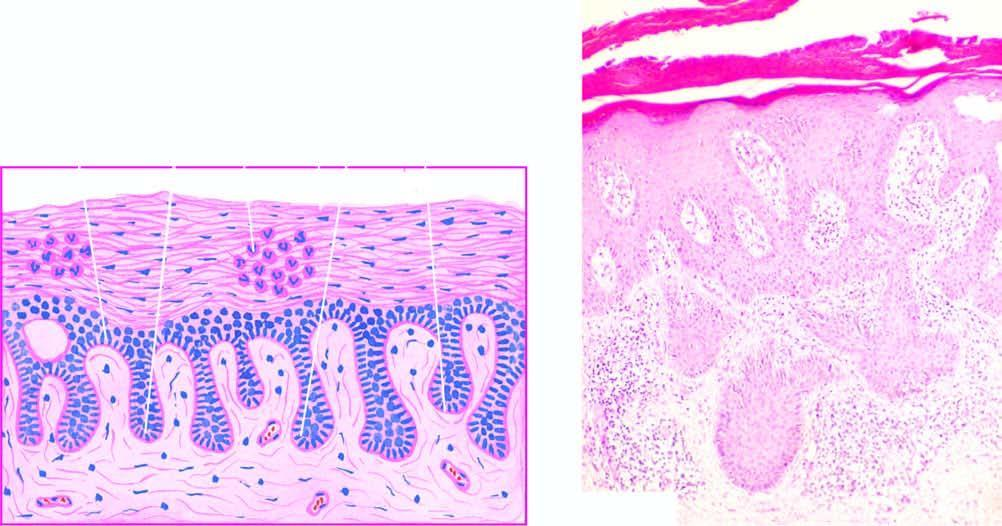re the papillae elongated and oedematous with suprapapillary thinning of epidermis?
Answer the question using a single word or phrase. Yes 